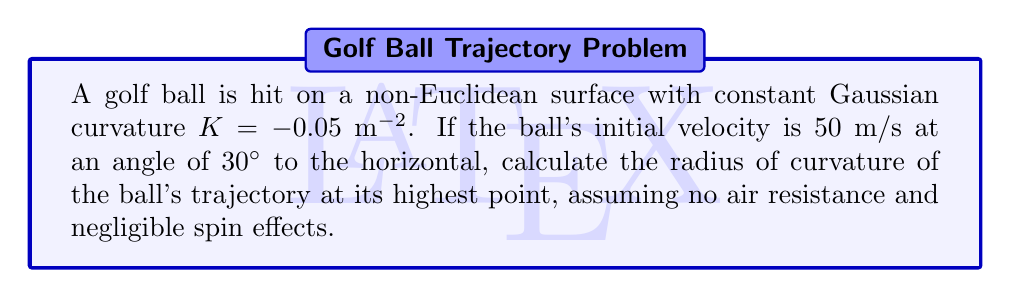Can you answer this question? Let's approach this step-by-step:

1) In a non-Euclidean space with constant negative curvature, the trajectory of a projectile follows a hyperbolic path. The radius of curvature at the highest point is given by:

   $$R = \frac{v^2}{g \cos^2 \theta} - \frac{1}{K}$$

   Where $v$ is the velocity, $g$ is the acceleration due to gravity, $\theta$ is the angle to the horizontal, and $K$ is the Gaussian curvature.

2) We're given:
   $K = -0.05$ $m^{-2}$
   $v = 50$ m/s
   $\theta = 30°$
   $g = 9.8$ m/s² (assumed standard gravity)

3) First, let's calculate $\cos^2 30°$:
   $$\cos^2 30° = (\frac{\sqrt{3}}{2})^2 = \frac{3}{4} = 0.75$$

4) Now, let's substitute these values into our equation:

   $$R = \frac{50^2}{9.8 \cdot 0.75} - \frac{1}{-0.05}$$

5) Simplify:
   $$R = \frac{2500}{7.35} + 20$$

6) Calculate:
   $$R \approx 340.14 + 20 = 360.14$$

Therefore, the radius of curvature at the highest point is approximately 360.14 meters.
Answer: $360.14$ m 